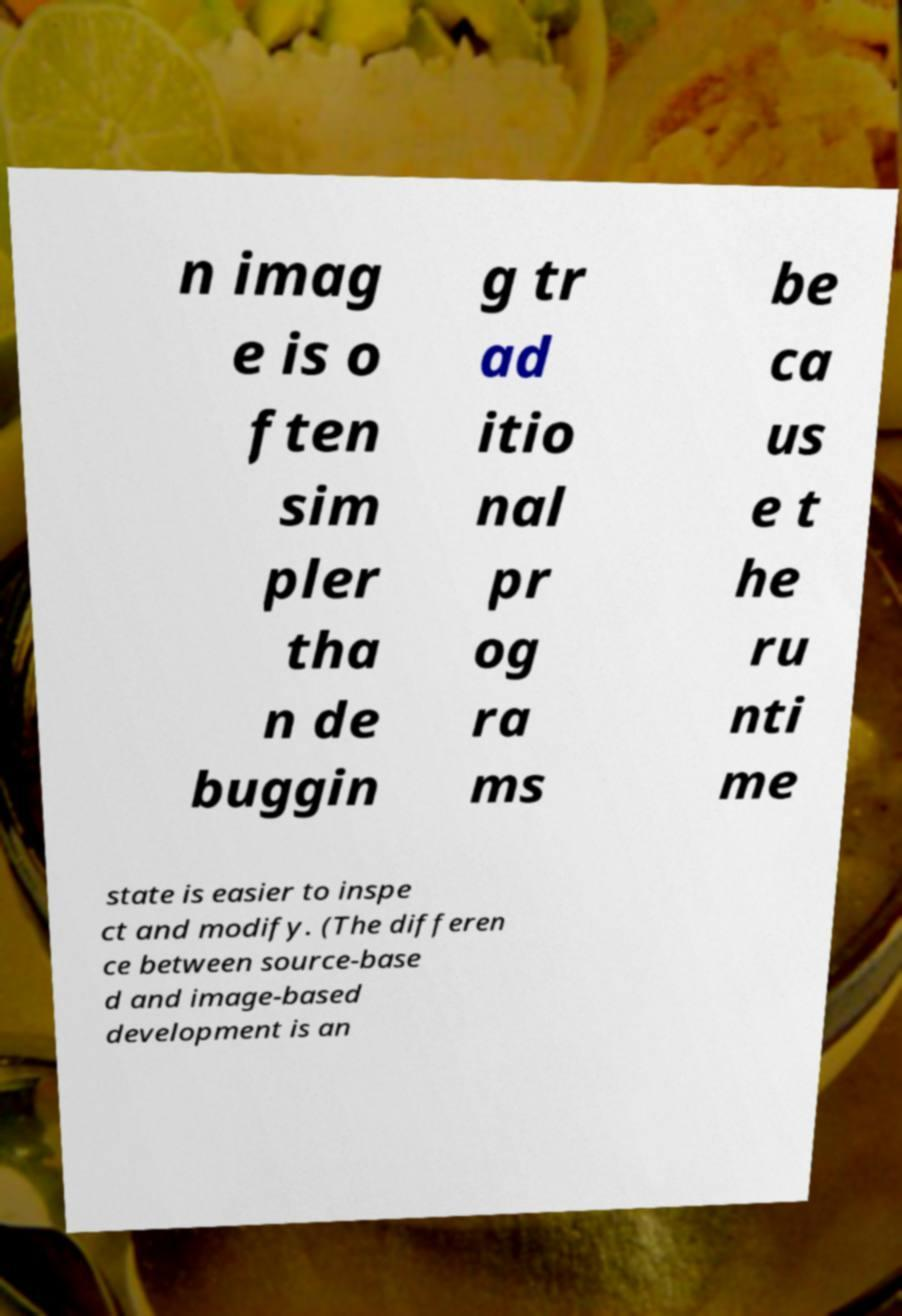Please identify and transcribe the text found in this image. n imag e is o ften sim pler tha n de buggin g tr ad itio nal pr og ra ms be ca us e t he ru nti me state is easier to inspe ct and modify. (The differen ce between source-base d and image-based development is an 